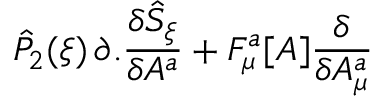<formula> <loc_0><loc_0><loc_500><loc_500>{ \hat { P } } _ { 2 } ( \xi ) \, \partial . \frac { \delta { \hat { S } } _ { \xi } } { \delta A ^ { a } } + F _ { \mu } ^ { a } [ A ] \frac { \delta } { \delta A _ { \mu } ^ { a } }</formula> 